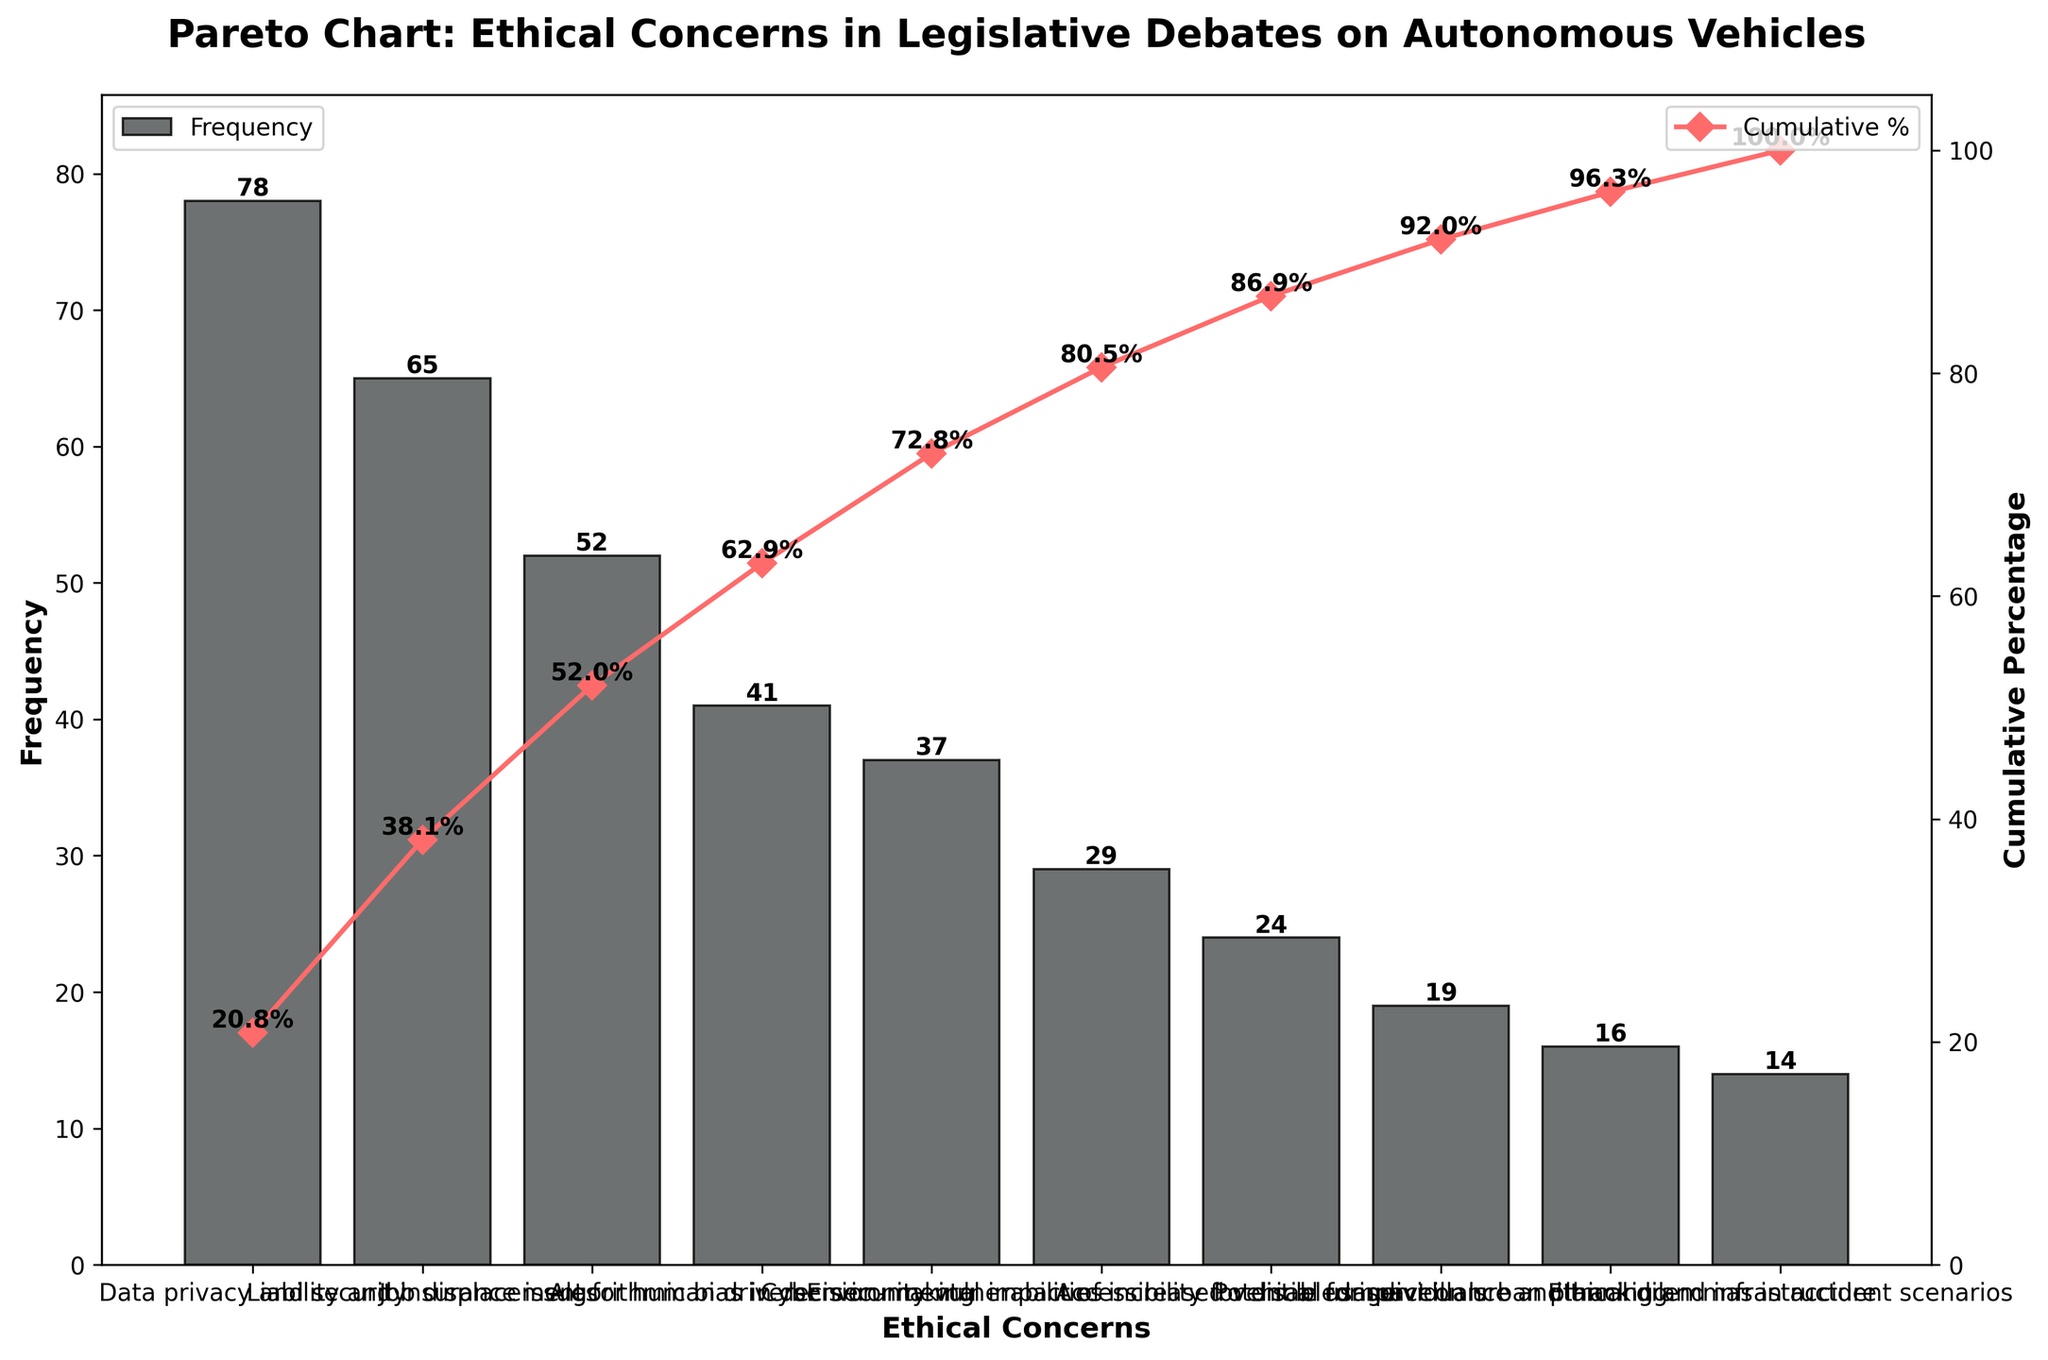Which ethical concern is mentioned the most frequently in legislative debates? By examining the bar chart, the tallest bar represents the most frequently mentioned concern, which is "Data privacy and security."
Answer: Data privacy and security What is the cumulative percentage of mentions covered by the top three ethical concerns? To find this, add the cumulative percentages of the top three concerns from the line graph. These are 34.9%, 64.0%, and 87.4%. So, the cumulative percentage is approximately 87.4%.
Answer: 87.4% Which ethical concern has the least frequency, and what is its cumulative percentage? The least frequent concern from the bar chart is "Ethical dilemmas in accident scenarios" with a frequency of 14. Its cumulative percentage can be read off the graph, which is approximately 97.5%.
Answer: Ethical dilemmas in accident scenarios, 97.5% How does the frequency of mentions of "Algorithmic bias in decision-making" compare to "Job displacement for human drivers"? From the bar chart, "Job displacement for human drivers" has a frequency of 52, while "Algorithmic bias in decision-making" has a frequency of 41. So, "Job displacement for human drivers" is mentioned more frequently.
Answer: Job displacement for human drivers is mentioned more frequently What is the cumulative percentage after including the first five ethical concerns? Add the cumulative percentages of the first five concerns from the line graph: 34.9%, 64.0%, 87.4%, 103.3%, and 118.0%. However, since the y-axis limits at 105%, the cumulative percentage at the fifth concern should be read directly, which is 103.3%. Since the graph limit is 105%, the phrasing requires cautious reading as some values overlap while retaining at cumulative at exact concern.
Answer: 103.3% Identify the ethical concern that has a frequency of mentions just below "Cybersecurity vulnerabilities." What is its frequency? The concern with the next highest frequency after "Cybersecurity vulnerabilities" (37 mentions) is "Environmental impact of increased vehicle usage," which has a frequency of 29 according to the bar chart.
Answer: Environmental impact of increased vehicle usage, 29 How many ethical concerns have a frequency of mentions less than 20? From the chart, the ethical concerns with fewer than 20 mentions are "Potential for surveillance and tracking" (19 mentions), "Impact on urban planning and infrastructure" (16 mentions), and "Ethical dilemmas in accident scenarios" (14 mentions). Therefore, there are three concerns.
Answer: 3 What is the difference in the number of mentions between "Liability and insurance issues" and "Accessibility for disabled individuals"? The frequency of mentions for "Liability and insurance issues" is 65, and for "Accessibility for disabled individuals," it is 24. The difference is 65 - 24 = 41.
Answer: 41 